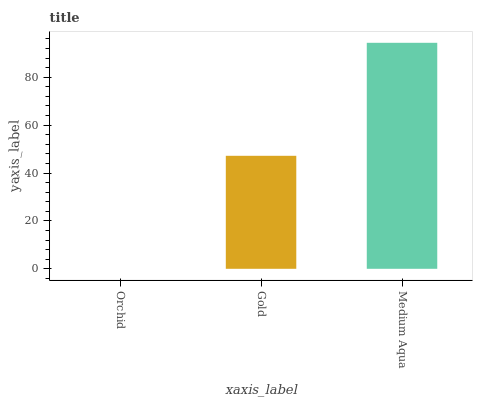Is Orchid the minimum?
Answer yes or no. Yes. Is Medium Aqua the maximum?
Answer yes or no. Yes. Is Gold the minimum?
Answer yes or no. No. Is Gold the maximum?
Answer yes or no. No. Is Gold greater than Orchid?
Answer yes or no. Yes. Is Orchid less than Gold?
Answer yes or no. Yes. Is Orchid greater than Gold?
Answer yes or no. No. Is Gold less than Orchid?
Answer yes or no. No. Is Gold the high median?
Answer yes or no. Yes. Is Gold the low median?
Answer yes or no. Yes. Is Orchid the high median?
Answer yes or no. No. Is Medium Aqua the low median?
Answer yes or no. No. 